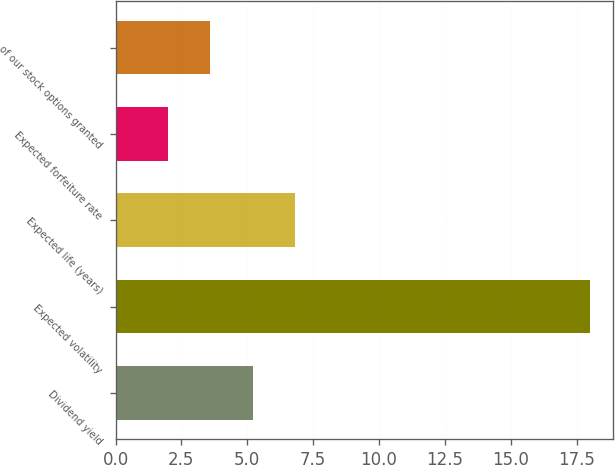<chart> <loc_0><loc_0><loc_500><loc_500><bar_chart><fcel>Dividend yield<fcel>Expected volatility<fcel>Expected life (years)<fcel>Expected forfeiture rate<fcel>of our stock options granted<nl><fcel>5.2<fcel>18<fcel>6.8<fcel>2<fcel>3.6<nl></chart> 